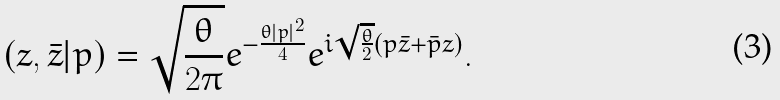<formula> <loc_0><loc_0><loc_500><loc_500>( z , \bar { z } | p ) = \sqrt { \frac { \theta } { 2 \pi } } e ^ { - \frac { \theta | p | ^ { 2 } } { 4 } } e ^ { i \sqrt { \frac { \theta } { 2 } } ( p \bar { z } + \bar { p } z ) } .</formula> 